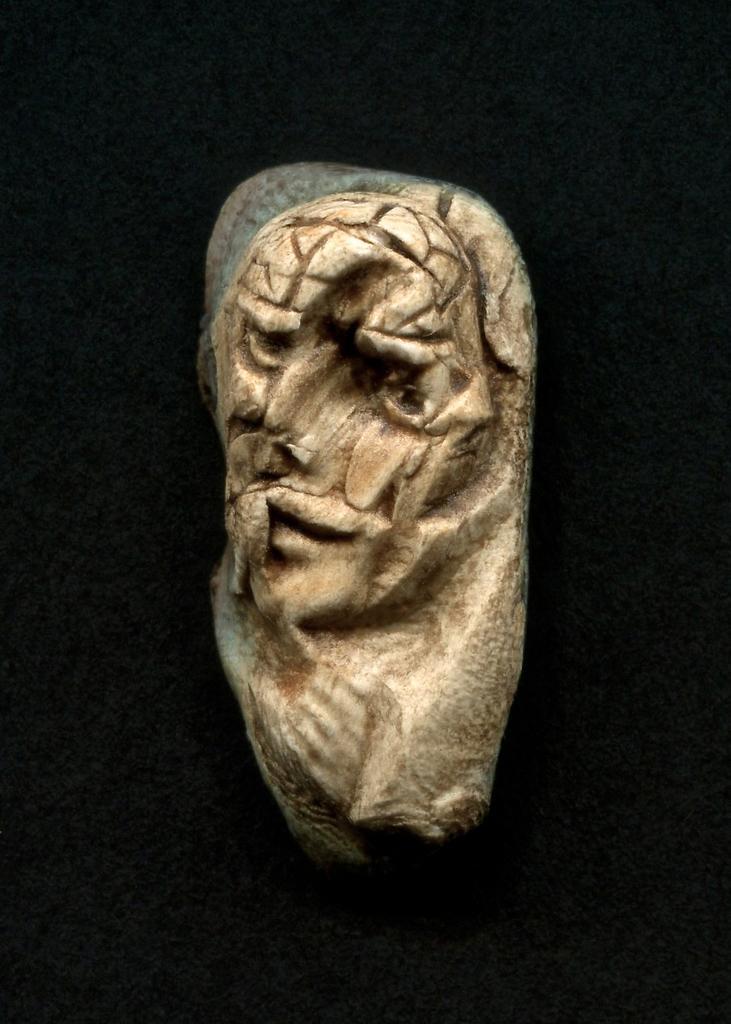In one or two sentences, can you explain what this image depicts? In this picture we can see a sculpture and in the background we can see black color. 